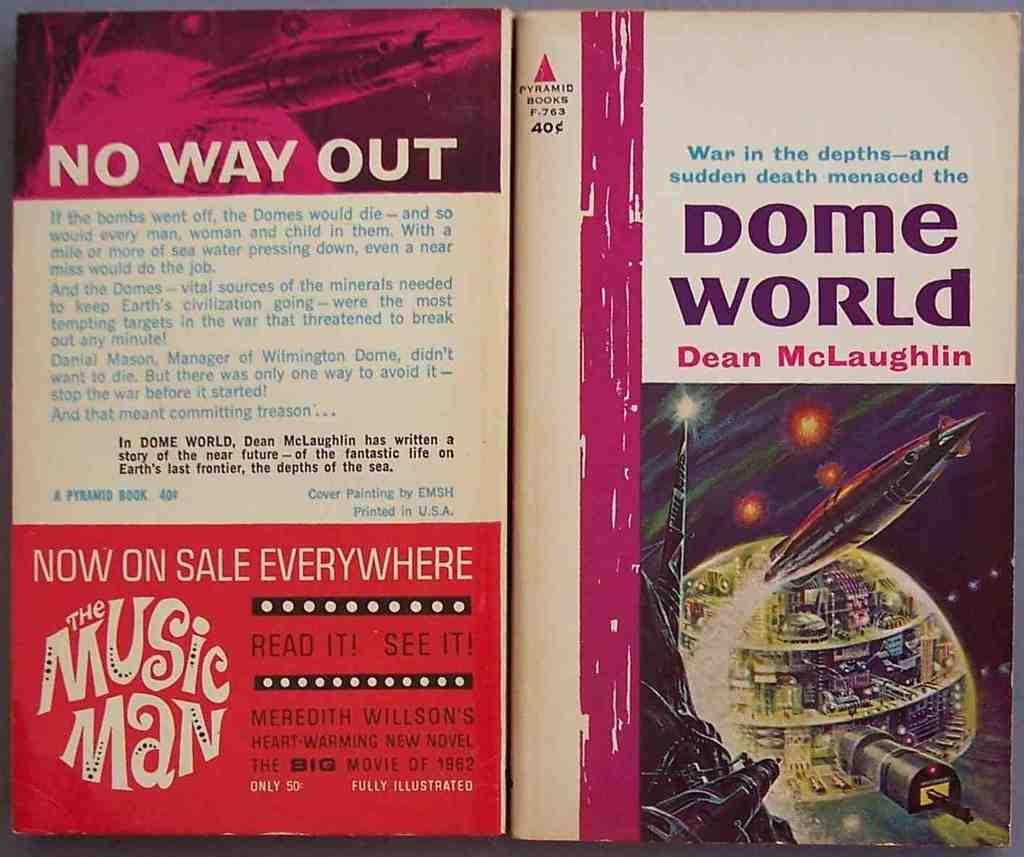Provide a one-sentence caption for the provided image. The front and back cover of a book titled "Dome World" by Dean McLaughlin tells about a book where people live in domes. 